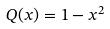<formula> <loc_0><loc_0><loc_500><loc_500>Q ( x ) = 1 - x ^ { 2 }</formula> 